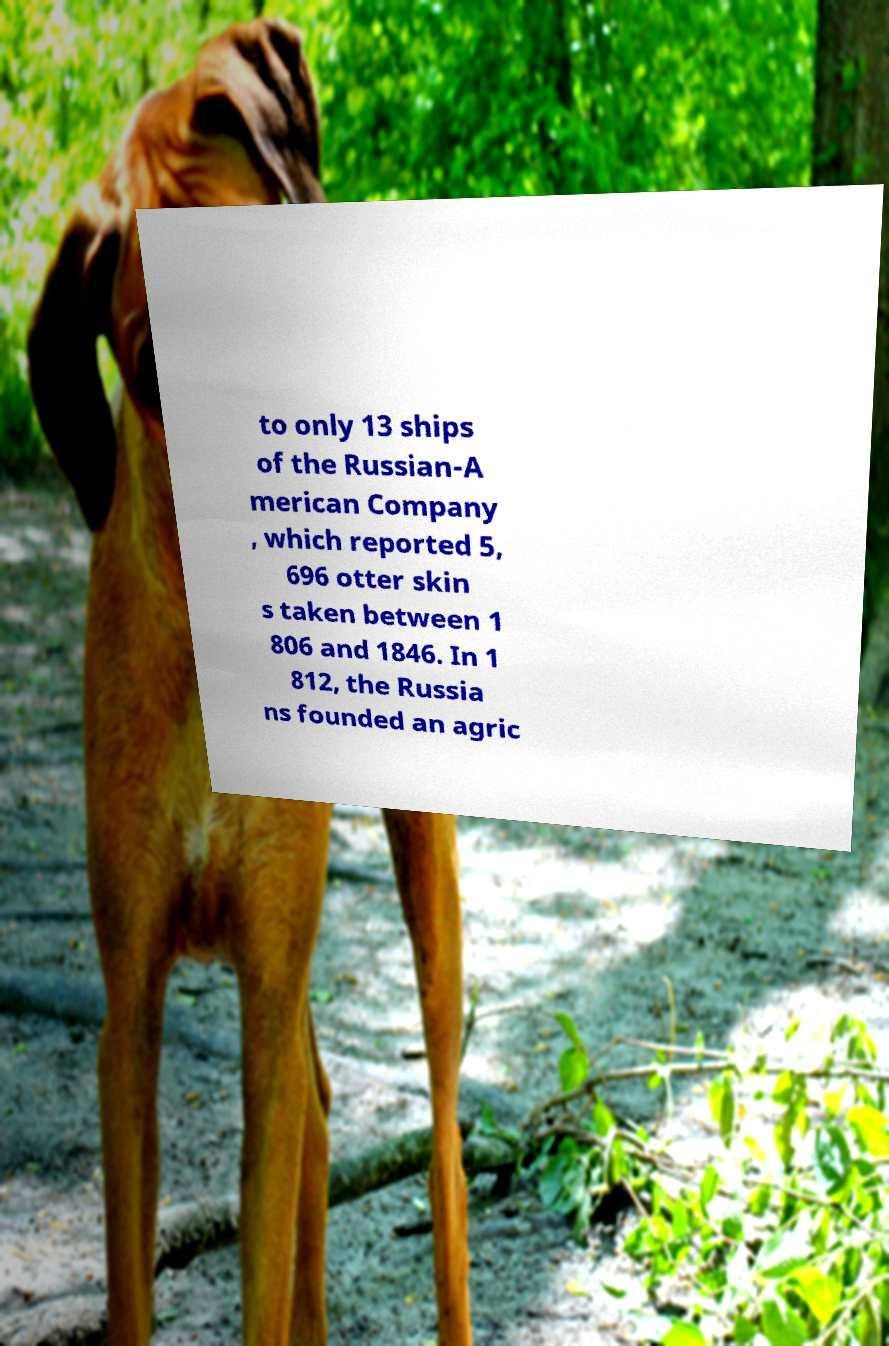Could you assist in decoding the text presented in this image and type it out clearly? to only 13 ships of the Russian-A merican Company , which reported 5, 696 otter skin s taken between 1 806 and 1846. In 1 812, the Russia ns founded an agric 